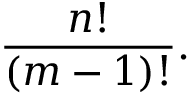<formula> <loc_0><loc_0><loc_500><loc_500>{ \frac { n ! } { ( m - 1 ) ! } } .</formula> 